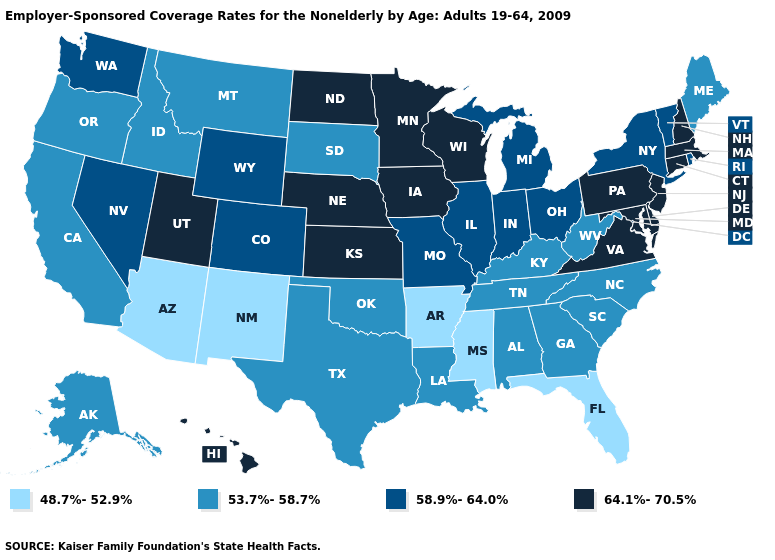Which states have the lowest value in the USA?
Concise answer only. Arizona, Arkansas, Florida, Mississippi, New Mexico. What is the highest value in the USA?
Answer briefly. 64.1%-70.5%. What is the value of Hawaii?
Write a very short answer. 64.1%-70.5%. Does the map have missing data?
Be succinct. No. What is the lowest value in states that border Pennsylvania?
Quick response, please. 53.7%-58.7%. Name the states that have a value in the range 48.7%-52.9%?
Quick response, please. Arizona, Arkansas, Florida, Mississippi, New Mexico. Does Florida have the lowest value in the USA?
Keep it brief. Yes. What is the value of Minnesota?
Write a very short answer. 64.1%-70.5%. Name the states that have a value in the range 53.7%-58.7%?
Be succinct. Alabama, Alaska, California, Georgia, Idaho, Kentucky, Louisiana, Maine, Montana, North Carolina, Oklahoma, Oregon, South Carolina, South Dakota, Tennessee, Texas, West Virginia. What is the value of South Carolina?
Write a very short answer. 53.7%-58.7%. Is the legend a continuous bar?
Quick response, please. No. What is the value of South Carolina?
Keep it brief. 53.7%-58.7%. Which states have the highest value in the USA?
Quick response, please. Connecticut, Delaware, Hawaii, Iowa, Kansas, Maryland, Massachusetts, Minnesota, Nebraska, New Hampshire, New Jersey, North Dakota, Pennsylvania, Utah, Virginia, Wisconsin. Does New Hampshire have the lowest value in the USA?
Answer briefly. No. 